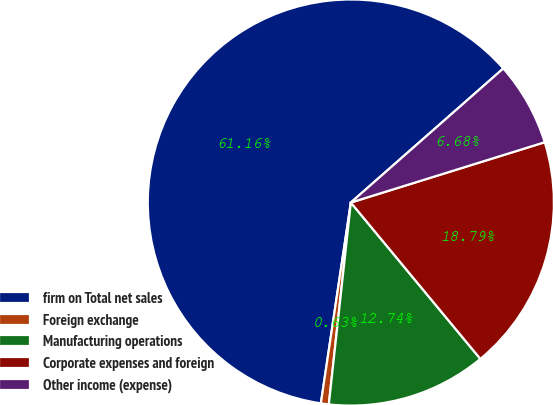Convert chart. <chart><loc_0><loc_0><loc_500><loc_500><pie_chart><fcel>firm on Total net sales<fcel>Foreign exchange<fcel>Manufacturing operations<fcel>Corporate expenses and foreign<fcel>Other income (expense)<nl><fcel>61.16%<fcel>0.63%<fcel>12.74%<fcel>18.79%<fcel>6.68%<nl></chart> 